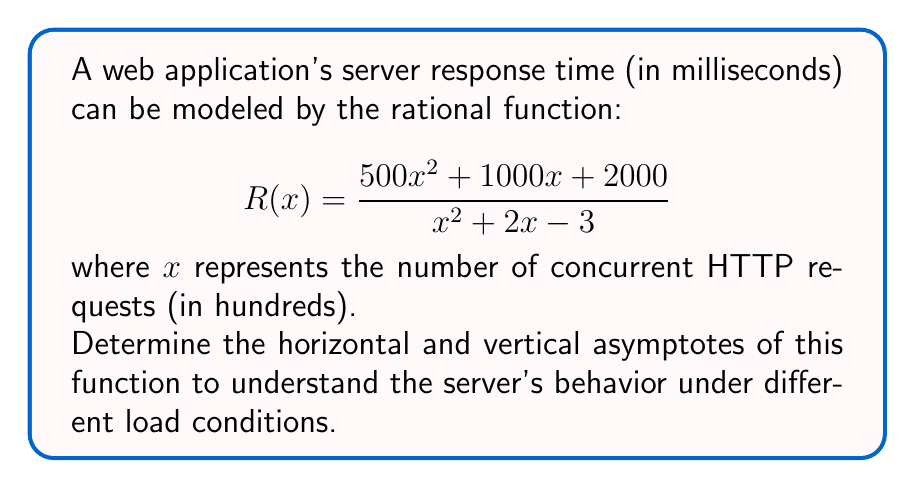Could you help me with this problem? To find the asymptotes of the rational function, we'll follow these steps:

1. Vertical asymptotes:
   Find the values of x that make the denominator zero.
   $$x^2 + 2x - 3 = 0$$
   $$(x + 3)(x - 1) = 0$$
   $$x = -3 \text{ or } x = 1$$
   
   The vertical asymptotes occur at $x = -3$ and $x = 1$.

2. Horizontal asymptote:
   Compare the degrees of the numerator and denominator.
   Numerator degree: 2
   Denominator degree: 2
   
   When degrees are equal, the horizontal asymptote is the ratio of the leading coefficients:
   $$\lim_{x \to \infty} \frac{500x^2}{x^2} = 500$$

3. Interpretation:
   - Vertical asymptotes at $x = -3$ and $x = 1$ indicate potential instability points. However, since $x$ represents hundreds of requests, negative values are not meaningful in this context.
   - The horizontal asymptote at $y = 500$ suggests that as the number of concurrent requests increases, the server response time approaches 500 milliseconds.
Answer: Vertical asymptotes: $x = 1$; Horizontal asymptote: $y = 500$ 